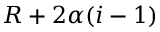Convert formula to latex. <formula><loc_0><loc_0><loc_500><loc_500>R + 2 \alpha ( i - 1 )</formula> 